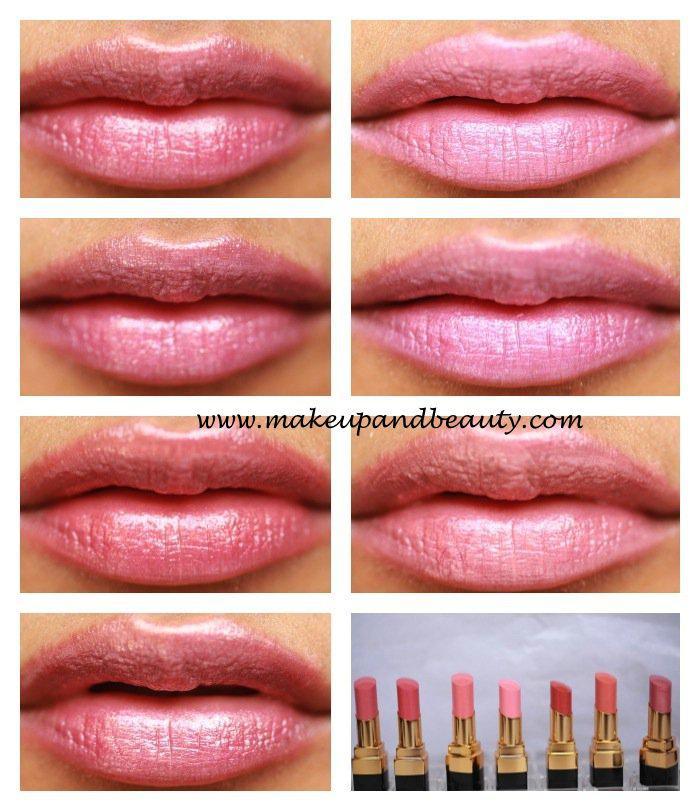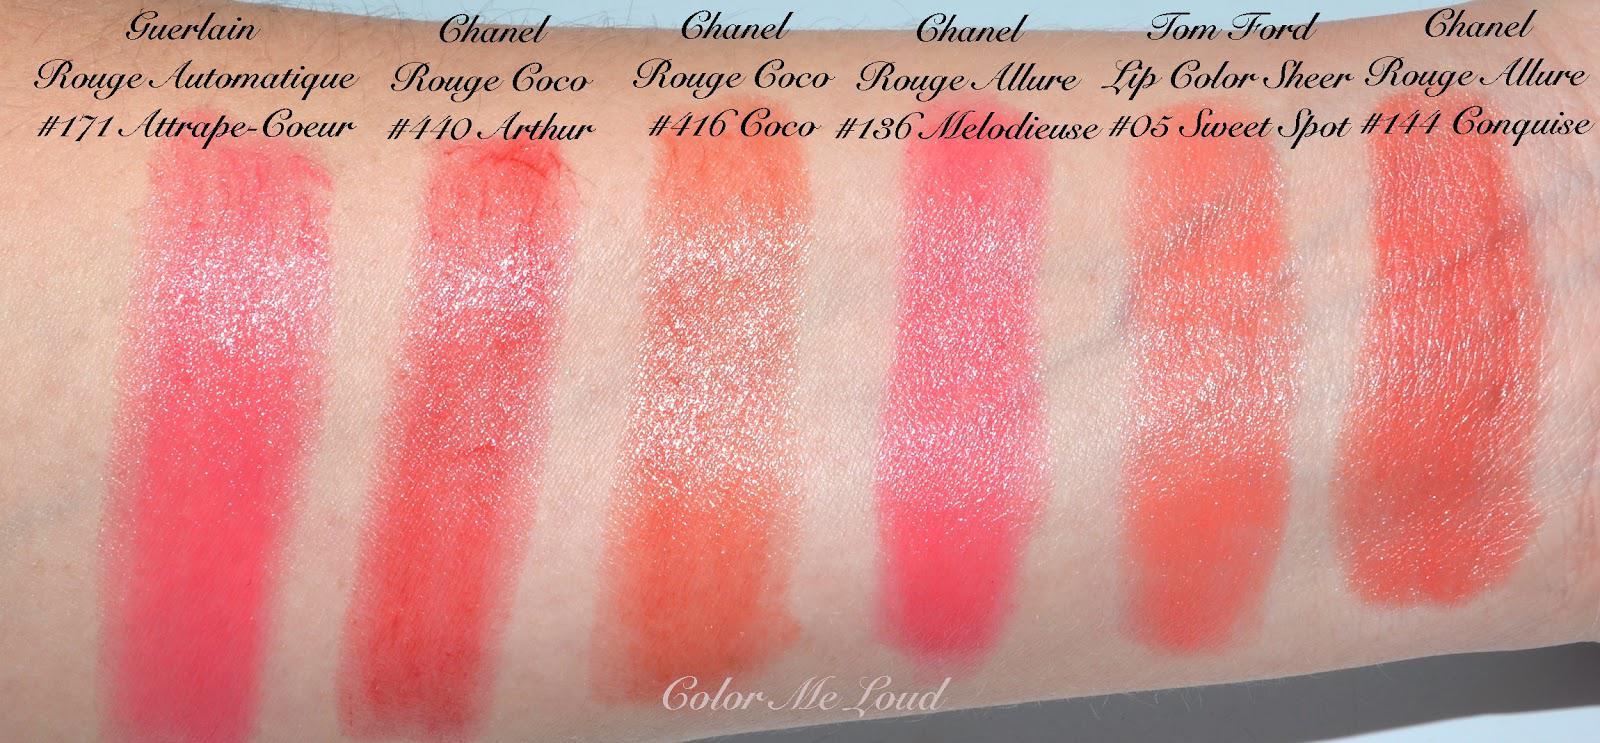The first image is the image on the left, the second image is the image on the right. For the images shown, is this caption "Differebt shades of lip stick are shoen on aerial view and above lipstick shades shown on human skin." true? Answer yes or no. No. The first image is the image on the left, the second image is the image on the right. Given the left and right images, does the statement "An image shows a row of lipstick pots above a row of lipstick streaks on human skin." hold true? Answer yes or no. No. 